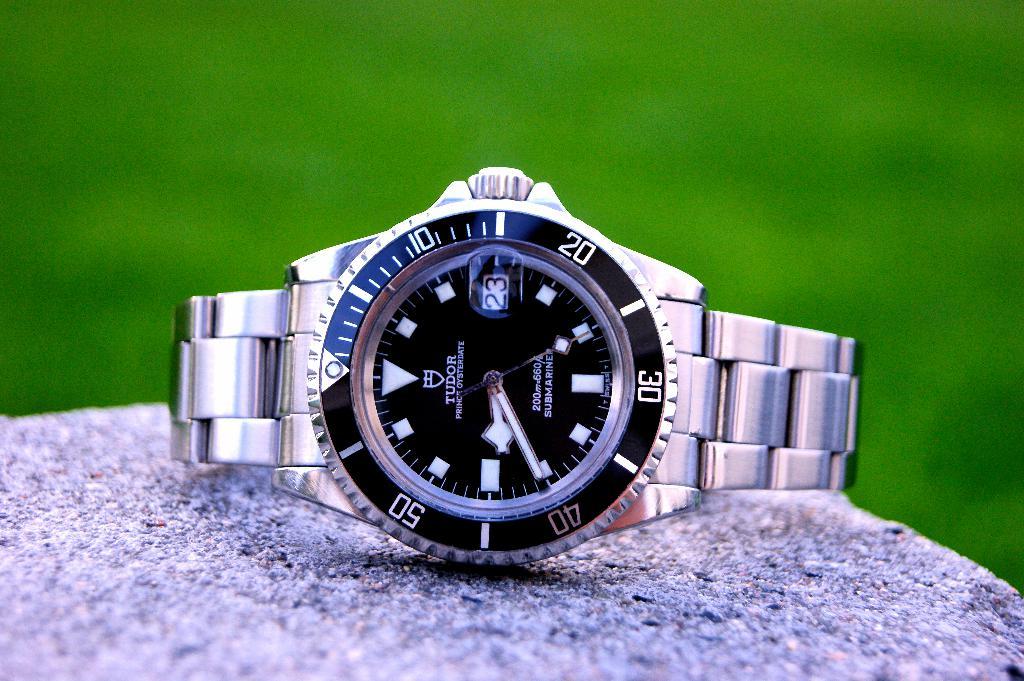What brand its?
Provide a succinct answer. Tudor. 